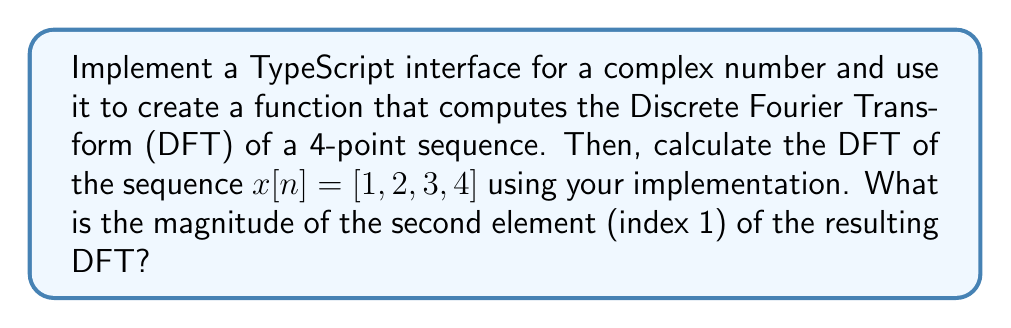Can you answer this question? Let's approach this step-by-step:

1. First, we need to define a TypeScript interface for complex numbers:

```typescript
interface Complex {
    real: number;
    imag: number;
}
```

2. Next, we'll implement a function to compute the DFT using this interface:

```typescript
function dft(x: number[]): Complex[] {
    const N = x.length;
    const X: Complex[] = [];
    for (let k = 0; k < N; k++) {
        let sum: Complex = {real: 0, imag: 0};
        for (let n = 0; n < N; n++) {
            const angle = -2 * Math.PI * k * n / N;
            sum.real += x[n] * Math.cos(angle);
            sum.imag += x[n] * Math.sin(angle);
        }
        X[k] = sum;
    }
    return X;
}
```

3. Now, let's compute the DFT of $x[n] = [1, 2, 3, 4]$:

```typescript
const x = [1, 2, 3, 4];
const X = dft(x);
```

4. The DFT result will be:

$$X[k] = [10, -2+2i, -2, -2-2i]$$

5. We're asked for the magnitude of the second element (index 1). The magnitude of a complex number $a + bi$ is given by $\sqrt{a^2 + b^2}$.

For $X[1] = -2 + 2i$:

$$|X[1]| = \sqrt{(-2)^2 + 2^2} = \sqrt{4 + 4} = \sqrt{8} = 2\sqrt{2}$$
Answer: $2\sqrt{2}$ 